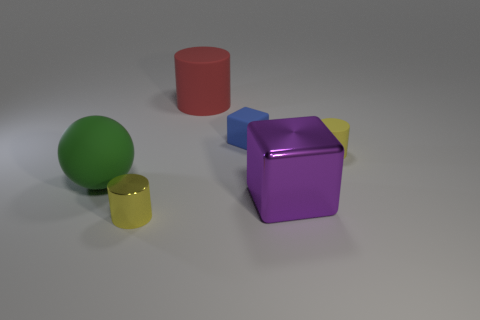Subtract all gray spheres. Subtract all brown cubes. How many spheres are left? 1 Add 2 large red objects. How many objects exist? 8 Subtract all balls. How many objects are left? 5 Subtract all yellow matte cylinders. Subtract all matte things. How many objects are left? 1 Add 4 big green balls. How many big green balls are left? 5 Add 4 gray metal cylinders. How many gray metal cylinders exist? 4 Subtract 2 yellow cylinders. How many objects are left? 4 